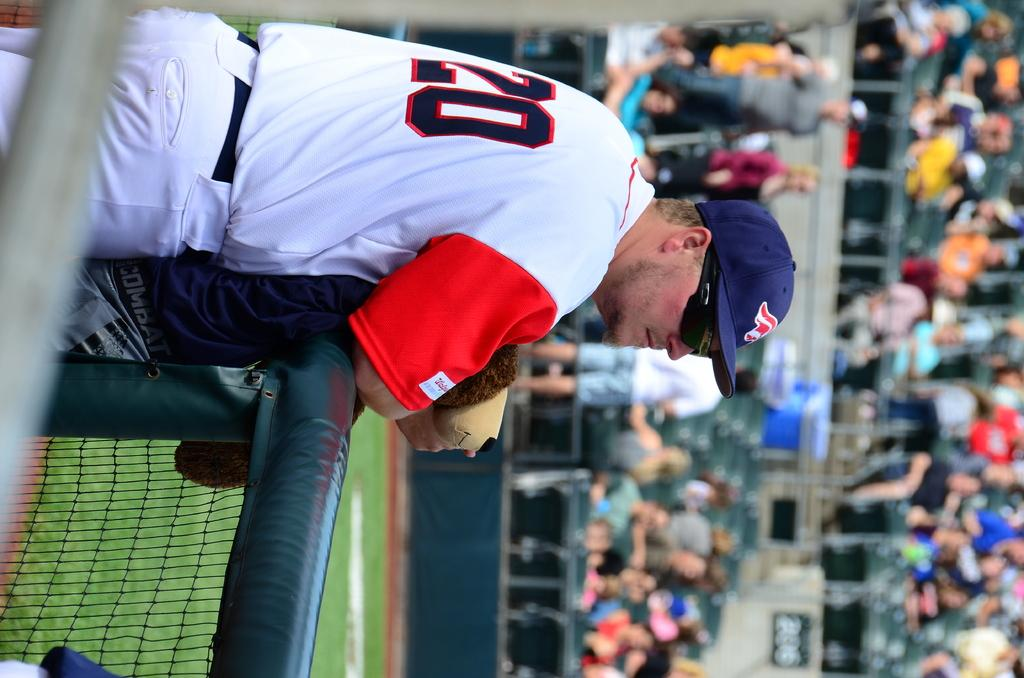<image>
Render a clear and concise summary of the photo. Player number 20 watches the game being played from the side of the field. 